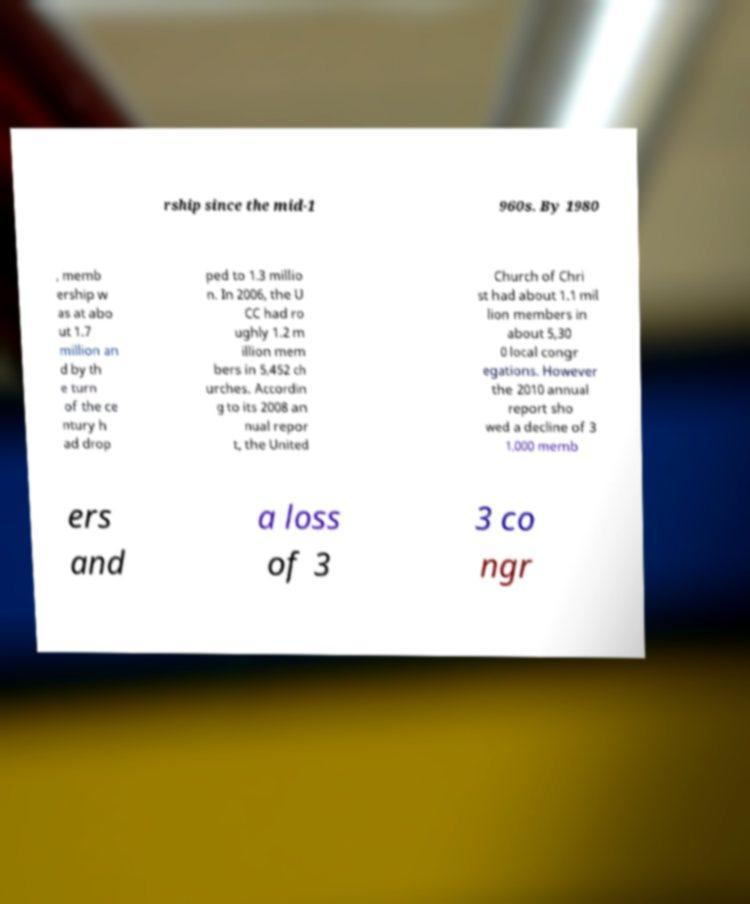Could you extract and type out the text from this image? rship since the mid-1 960s. By 1980 , memb ership w as at abo ut 1.7 million an d by th e turn of the ce ntury h ad drop ped to 1.3 millio n. In 2006, the U CC had ro ughly 1.2 m illion mem bers in 5,452 ch urches. Accordin g to its 2008 an nual repor t, the United Church of Chri st had about 1.1 mil lion members in about 5,30 0 local congr egations. However the 2010 annual report sho wed a decline of 3 1,000 memb ers and a loss of 3 3 co ngr 